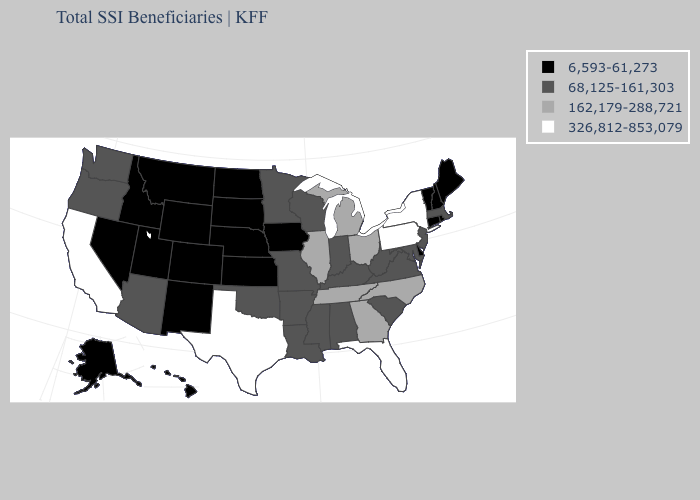What is the value of Maryland?
Write a very short answer. 68,125-161,303. Does Wyoming have the lowest value in the USA?
Answer briefly. Yes. Does the map have missing data?
Quick response, please. No. Among the states that border North Dakota , which have the lowest value?
Short answer required. Montana, South Dakota. What is the value of New Mexico?
Answer briefly. 6,593-61,273. Does Florida have the highest value in the USA?
Quick response, please. Yes. Among the states that border Minnesota , does Wisconsin have the lowest value?
Keep it brief. No. What is the highest value in the USA?
Quick response, please. 326,812-853,079. Name the states that have a value in the range 162,179-288,721?
Quick response, please. Georgia, Illinois, Michigan, North Carolina, Ohio, Tennessee. Name the states that have a value in the range 162,179-288,721?
Short answer required. Georgia, Illinois, Michigan, North Carolina, Ohio, Tennessee. Among the states that border Mississippi , which have the highest value?
Give a very brief answer. Tennessee. How many symbols are there in the legend?
Give a very brief answer. 4. Does Florida have a lower value than Vermont?
Answer briefly. No. What is the value of Iowa?
Concise answer only. 6,593-61,273. What is the value of North Carolina?
Be succinct. 162,179-288,721. 